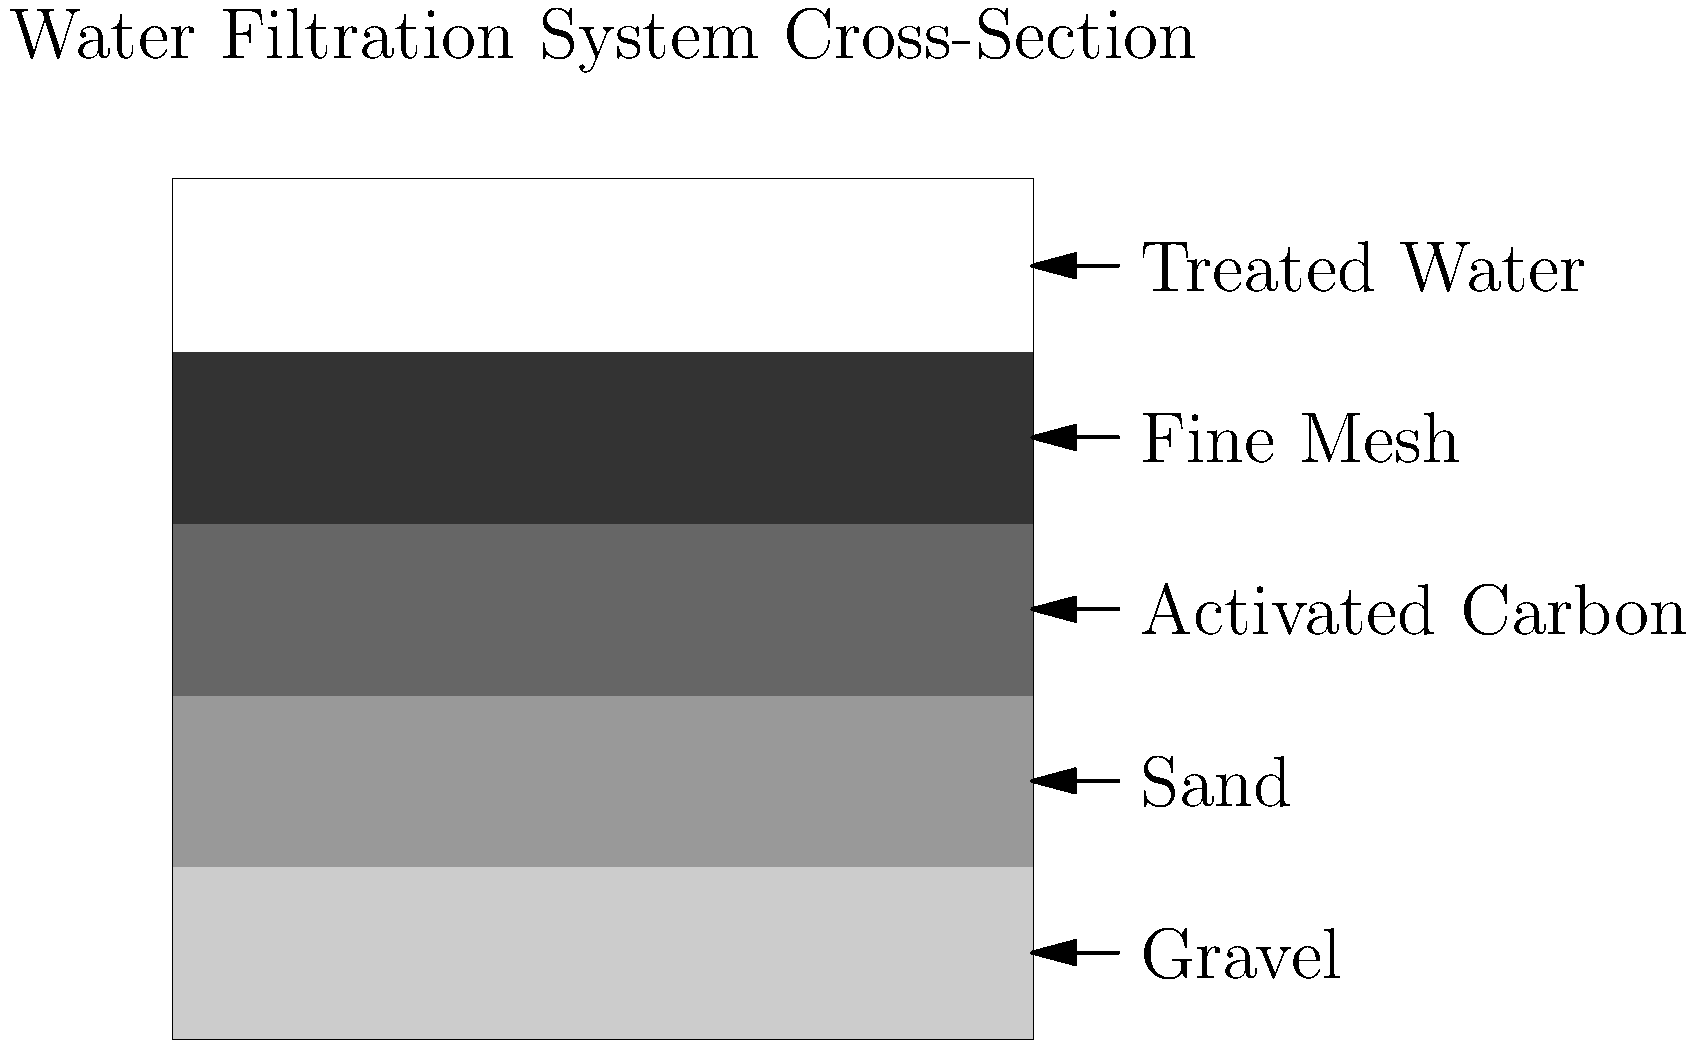In designing a water filtration system for a pediatric clinic, which layer of the filtration system shown in the cross-section is primarily responsible for removing chemical contaminants and improving water taste and odor? To answer this question, let's examine the layers of the water filtration system shown in the cross-section:

1. The bottom layer is gravel, which acts as a support layer and helps with water distribution.
2. Above the gravel is sand, which filters out larger particles and some microorganisms.
3. The middle layer is activated carbon, which is known for its ability to remove chemical contaminants, as well as improve taste and odor.
4. The next layer is a fine mesh, which helps remove smaller particles that may have passed through the previous layers.
5. The top layer represents the treated water after filtration.

Among these layers, activated carbon is specifically designed to adsorb chemical contaminants and organic compounds. It has a large surface area and porous structure that allows it to trap various chemicals, chlorine, and organic matter that can affect taste and odor.

Therefore, the activated carbon layer is primarily responsible for removing chemical contaminants and improving water taste and odor in this filtration system.
Answer: Activated carbon layer 